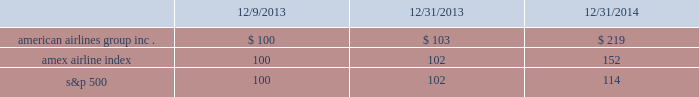Table of contents stock performance graph the following stock performance graph and related information shall not be deemed 201csoliciting material 201d or 201cfiled 201d with the securities and exchange commission , nor shall such information be incorporated by reference into any future filings under the securities act of 1933 or the exchange act , each as amended , except to the extent that we specifically incorporate it by reference into such filing .
The following stock performance graph compares our cumulative total shareholder return on an annual basis on our common stock with the cumulative total return on the standard and poor 2019s 500 stock index and the amex airline index from december 9 , 2013 ( the first trading day of aag common stock ) through december 31 , 2014 .
The comparison assumes $ 100 was invested on december 9 , 2013 in aag common stock and in each of the foregoing indices and assumes reinvestment of dividends .
The stock performance shown on the graph below represents historical stock performance and is not necessarily indicative of future stock price performance. .

What was the 3 year return of american airlines group inc.? 
Computations: ((219 - 100) / 100)
Answer: 1.19. 